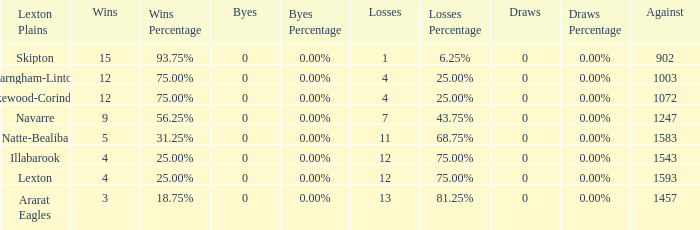What team has fewer than 9 wins and less than 1593 against? Natte-Bealiba, Illabarook, Ararat Eagles. 